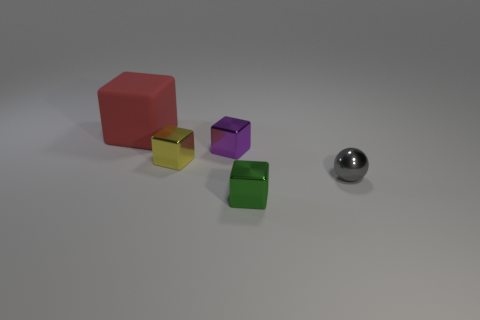There is a tiny shiny thing behind the yellow shiny object; is it the same shape as the gray object?
Make the answer very short. No. Are there fewer tiny balls in front of the small metal sphere than tiny purple metal objects that are behind the red thing?
Provide a short and direct response. No. There is a block that is behind the purple object; what is its material?
Offer a terse response. Rubber. Is there a green thing of the same size as the purple shiny block?
Make the answer very short. Yes. There is a green metallic object; is it the same shape as the small thing that is left of the small purple cube?
Make the answer very short. Yes. There is a block that is behind the purple block; is its size the same as the shiny block that is in front of the tiny yellow metal thing?
Offer a very short reply. No. What number of other things are there of the same shape as the small purple object?
Provide a succinct answer. 3. There is a cube that is behind the tiny shiny block that is behind the tiny yellow thing; what is its material?
Keep it short and to the point. Rubber. What number of metal objects are big blue blocks or objects?
Offer a terse response. 4. Are there any other things that have the same material as the red thing?
Ensure brevity in your answer.  No. 